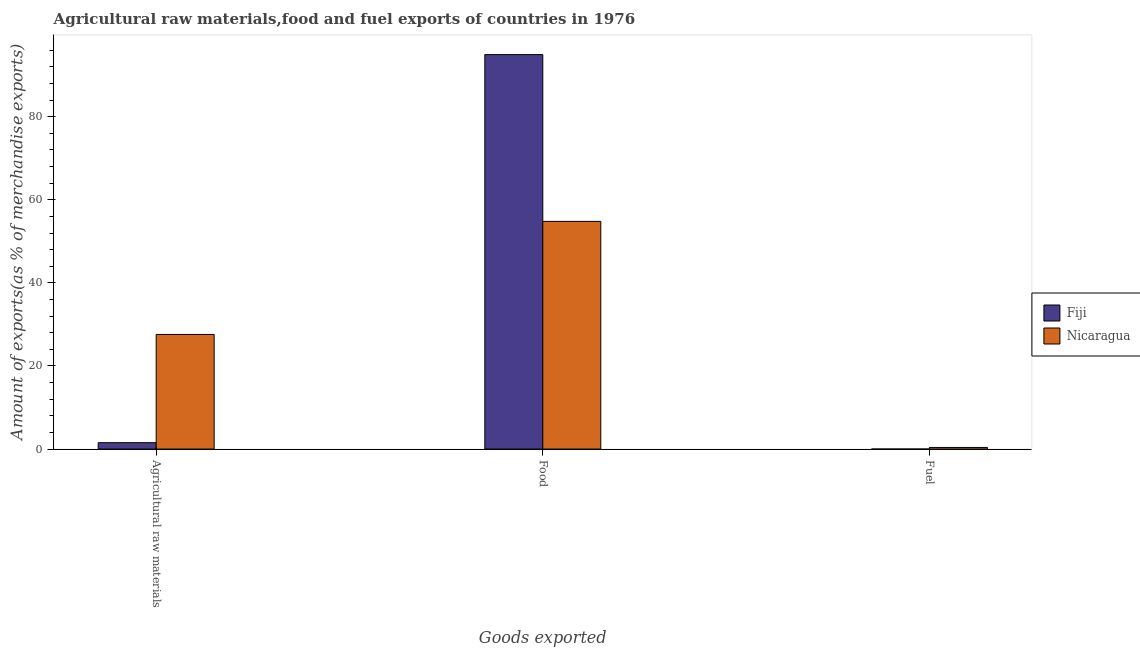How many different coloured bars are there?
Your answer should be very brief. 2. How many groups of bars are there?
Ensure brevity in your answer.  3. Are the number of bars per tick equal to the number of legend labels?
Offer a terse response. Yes. Are the number of bars on each tick of the X-axis equal?
Provide a succinct answer. Yes. How many bars are there on the 3rd tick from the right?
Provide a succinct answer. 2. What is the label of the 2nd group of bars from the left?
Give a very brief answer. Food. What is the percentage of raw materials exports in Fiji?
Your answer should be very brief. 1.54. Across all countries, what is the maximum percentage of food exports?
Provide a succinct answer. 94.94. Across all countries, what is the minimum percentage of fuel exports?
Give a very brief answer. 0. In which country was the percentage of food exports maximum?
Your answer should be compact. Fiji. In which country was the percentage of raw materials exports minimum?
Give a very brief answer. Fiji. What is the total percentage of food exports in the graph?
Your answer should be compact. 149.74. What is the difference between the percentage of food exports in Nicaragua and that in Fiji?
Your response must be concise. -40.14. What is the difference between the percentage of raw materials exports in Nicaragua and the percentage of food exports in Fiji?
Provide a succinct answer. -67.35. What is the average percentage of raw materials exports per country?
Your answer should be compact. 14.57. What is the difference between the percentage of fuel exports and percentage of food exports in Fiji?
Provide a succinct answer. -94.94. What is the ratio of the percentage of raw materials exports in Nicaragua to that in Fiji?
Your answer should be compact. 17.91. Is the percentage of raw materials exports in Nicaragua less than that in Fiji?
Give a very brief answer. No. What is the difference between the highest and the second highest percentage of raw materials exports?
Keep it short and to the point. 26.05. What is the difference between the highest and the lowest percentage of food exports?
Give a very brief answer. 40.14. In how many countries, is the percentage of raw materials exports greater than the average percentage of raw materials exports taken over all countries?
Make the answer very short. 1. Is the sum of the percentage of food exports in Fiji and Nicaragua greater than the maximum percentage of fuel exports across all countries?
Your response must be concise. Yes. What does the 1st bar from the left in Food represents?
Offer a very short reply. Fiji. What does the 2nd bar from the right in Food represents?
Ensure brevity in your answer.  Fiji. Is it the case that in every country, the sum of the percentage of raw materials exports and percentage of food exports is greater than the percentage of fuel exports?
Give a very brief answer. Yes. Are all the bars in the graph horizontal?
Offer a very short reply. No. What is the difference between two consecutive major ticks on the Y-axis?
Give a very brief answer. 20. Where does the legend appear in the graph?
Provide a succinct answer. Center right. How are the legend labels stacked?
Offer a terse response. Vertical. What is the title of the graph?
Your answer should be very brief. Agricultural raw materials,food and fuel exports of countries in 1976. What is the label or title of the X-axis?
Your answer should be very brief. Goods exported. What is the label or title of the Y-axis?
Make the answer very short. Amount of exports(as % of merchandise exports). What is the Amount of exports(as % of merchandise exports) of Fiji in Agricultural raw materials?
Provide a succinct answer. 1.54. What is the Amount of exports(as % of merchandise exports) in Nicaragua in Agricultural raw materials?
Make the answer very short. 27.59. What is the Amount of exports(as % of merchandise exports) of Fiji in Food?
Make the answer very short. 94.94. What is the Amount of exports(as % of merchandise exports) in Nicaragua in Food?
Offer a very short reply. 54.8. What is the Amount of exports(as % of merchandise exports) in Fiji in Fuel?
Provide a short and direct response. 0. What is the Amount of exports(as % of merchandise exports) in Nicaragua in Fuel?
Your answer should be very brief. 0.39. Across all Goods exported, what is the maximum Amount of exports(as % of merchandise exports) in Fiji?
Make the answer very short. 94.94. Across all Goods exported, what is the maximum Amount of exports(as % of merchandise exports) of Nicaragua?
Keep it short and to the point. 54.8. Across all Goods exported, what is the minimum Amount of exports(as % of merchandise exports) of Fiji?
Ensure brevity in your answer.  0. Across all Goods exported, what is the minimum Amount of exports(as % of merchandise exports) in Nicaragua?
Your answer should be compact. 0.39. What is the total Amount of exports(as % of merchandise exports) of Fiji in the graph?
Give a very brief answer. 96.48. What is the total Amount of exports(as % of merchandise exports) in Nicaragua in the graph?
Offer a terse response. 82.79. What is the difference between the Amount of exports(as % of merchandise exports) in Fiji in Agricultural raw materials and that in Food?
Your answer should be compact. -93.4. What is the difference between the Amount of exports(as % of merchandise exports) in Nicaragua in Agricultural raw materials and that in Food?
Provide a short and direct response. -27.21. What is the difference between the Amount of exports(as % of merchandise exports) of Fiji in Agricultural raw materials and that in Fuel?
Your answer should be very brief. 1.54. What is the difference between the Amount of exports(as % of merchandise exports) in Nicaragua in Agricultural raw materials and that in Fuel?
Give a very brief answer. 27.2. What is the difference between the Amount of exports(as % of merchandise exports) of Fiji in Food and that in Fuel?
Your answer should be very brief. 94.94. What is the difference between the Amount of exports(as % of merchandise exports) of Nicaragua in Food and that in Fuel?
Offer a terse response. 54.41. What is the difference between the Amount of exports(as % of merchandise exports) in Fiji in Agricultural raw materials and the Amount of exports(as % of merchandise exports) in Nicaragua in Food?
Give a very brief answer. -53.26. What is the difference between the Amount of exports(as % of merchandise exports) in Fiji in Agricultural raw materials and the Amount of exports(as % of merchandise exports) in Nicaragua in Fuel?
Make the answer very short. 1.15. What is the difference between the Amount of exports(as % of merchandise exports) of Fiji in Food and the Amount of exports(as % of merchandise exports) of Nicaragua in Fuel?
Your answer should be very brief. 94.55. What is the average Amount of exports(as % of merchandise exports) in Fiji per Goods exported?
Give a very brief answer. 32.16. What is the average Amount of exports(as % of merchandise exports) in Nicaragua per Goods exported?
Your answer should be very brief. 27.6. What is the difference between the Amount of exports(as % of merchandise exports) in Fiji and Amount of exports(as % of merchandise exports) in Nicaragua in Agricultural raw materials?
Give a very brief answer. -26.05. What is the difference between the Amount of exports(as % of merchandise exports) of Fiji and Amount of exports(as % of merchandise exports) of Nicaragua in Food?
Your answer should be very brief. 40.14. What is the difference between the Amount of exports(as % of merchandise exports) of Fiji and Amount of exports(as % of merchandise exports) of Nicaragua in Fuel?
Give a very brief answer. -0.39. What is the ratio of the Amount of exports(as % of merchandise exports) in Fiji in Agricultural raw materials to that in Food?
Ensure brevity in your answer.  0.02. What is the ratio of the Amount of exports(as % of merchandise exports) in Nicaragua in Agricultural raw materials to that in Food?
Your answer should be compact. 0.5. What is the ratio of the Amount of exports(as % of merchandise exports) in Fiji in Agricultural raw materials to that in Fuel?
Offer a terse response. 2939.64. What is the ratio of the Amount of exports(as % of merchandise exports) of Nicaragua in Agricultural raw materials to that in Fuel?
Provide a short and direct response. 70.03. What is the ratio of the Amount of exports(as % of merchandise exports) of Fiji in Food to that in Fuel?
Offer a terse response. 1.81e+05. What is the ratio of the Amount of exports(as % of merchandise exports) of Nicaragua in Food to that in Fuel?
Your response must be concise. 139.1. What is the difference between the highest and the second highest Amount of exports(as % of merchandise exports) of Fiji?
Give a very brief answer. 93.4. What is the difference between the highest and the second highest Amount of exports(as % of merchandise exports) of Nicaragua?
Your answer should be compact. 27.21. What is the difference between the highest and the lowest Amount of exports(as % of merchandise exports) of Fiji?
Offer a very short reply. 94.94. What is the difference between the highest and the lowest Amount of exports(as % of merchandise exports) in Nicaragua?
Ensure brevity in your answer.  54.41. 